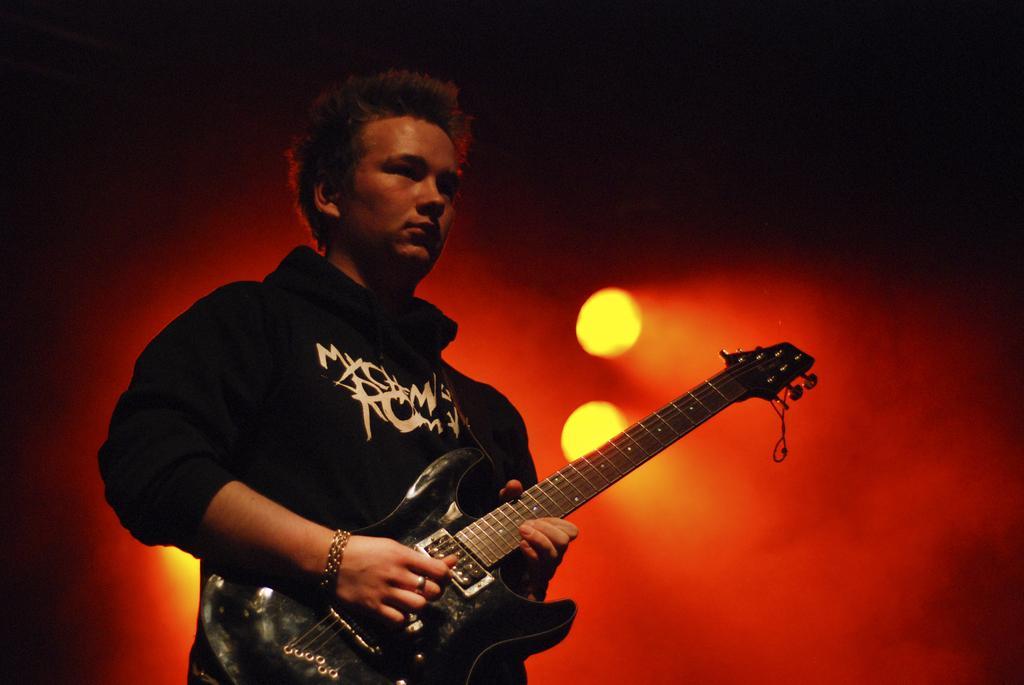Describe this image in one or two sentences. In the given image we can see a man wearing black color jacket and holding guitar in his hands. Back of his there is a red light emitting. 